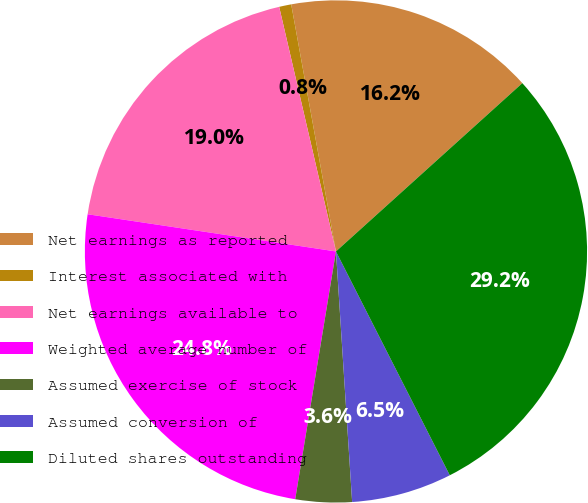Convert chart to OTSL. <chart><loc_0><loc_0><loc_500><loc_500><pie_chart><fcel>Net earnings as reported<fcel>Interest associated with<fcel>Net earnings available to<fcel>Weighted average number of<fcel>Assumed exercise of stock<fcel>Assumed conversion of<fcel>Diluted shares outstanding<nl><fcel>16.16%<fcel>0.78%<fcel>19.0%<fcel>24.77%<fcel>3.62%<fcel>6.46%<fcel>29.2%<nl></chart> 